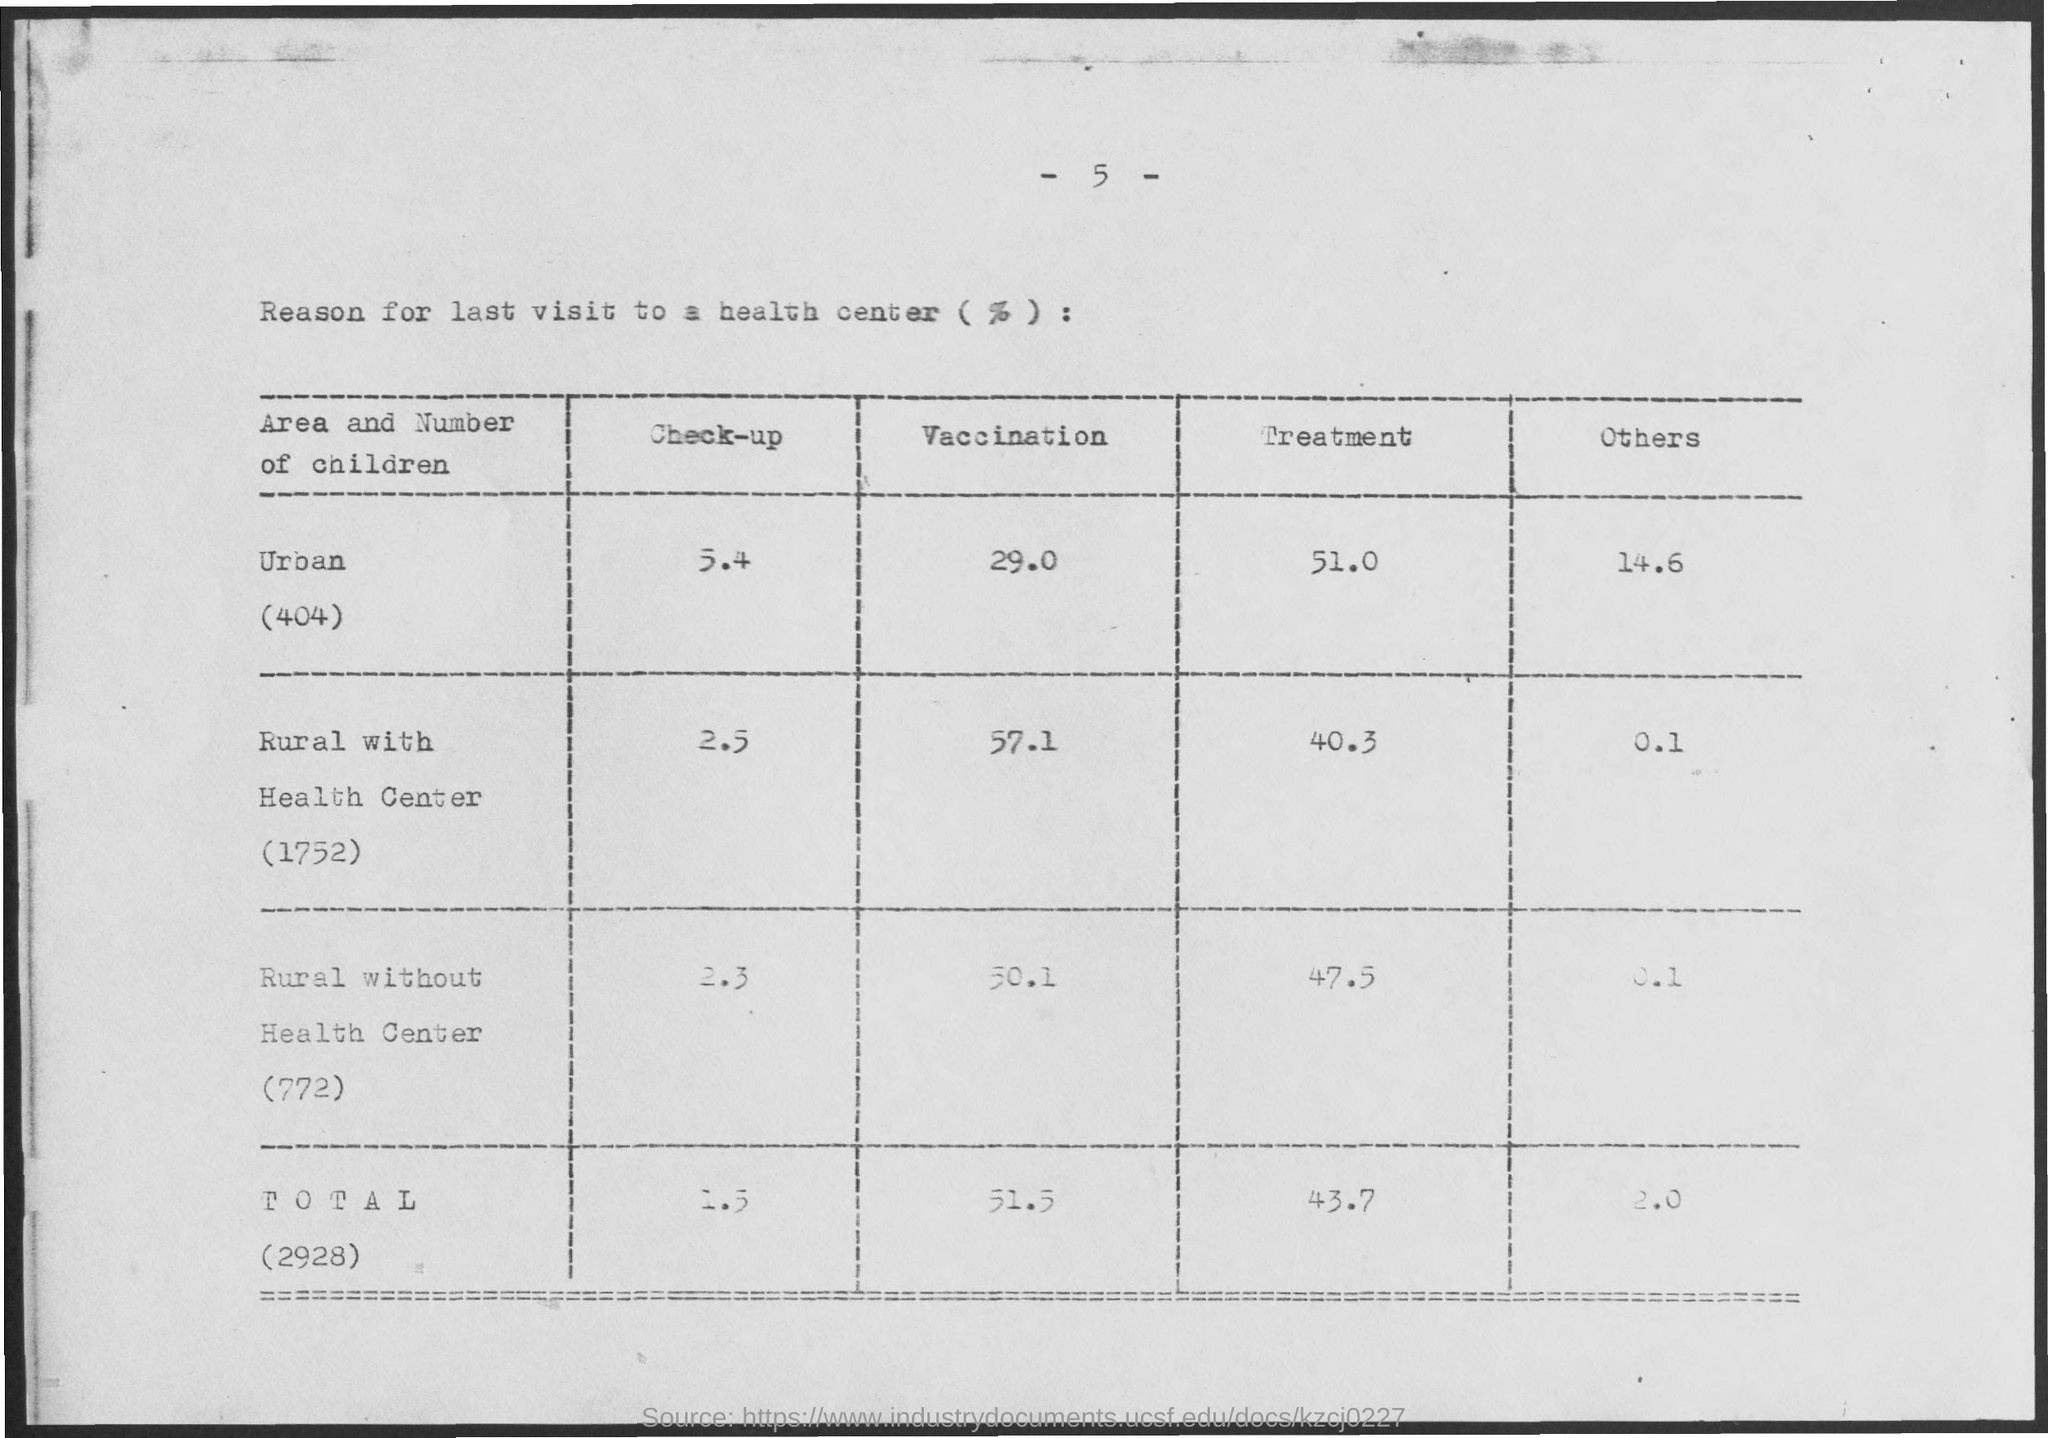Identify some key points in this picture. The title of the table is 'Reason for last visit to a health center (%)', which provides information on the percentage of individuals who visited a health center in the last year. In the rural area, 57.1% of children who visited a health center received vaccinations. According to the data, 51.0% of children from urban areas sought treatment. There were 404 children who were categorized as urban in the given information. 